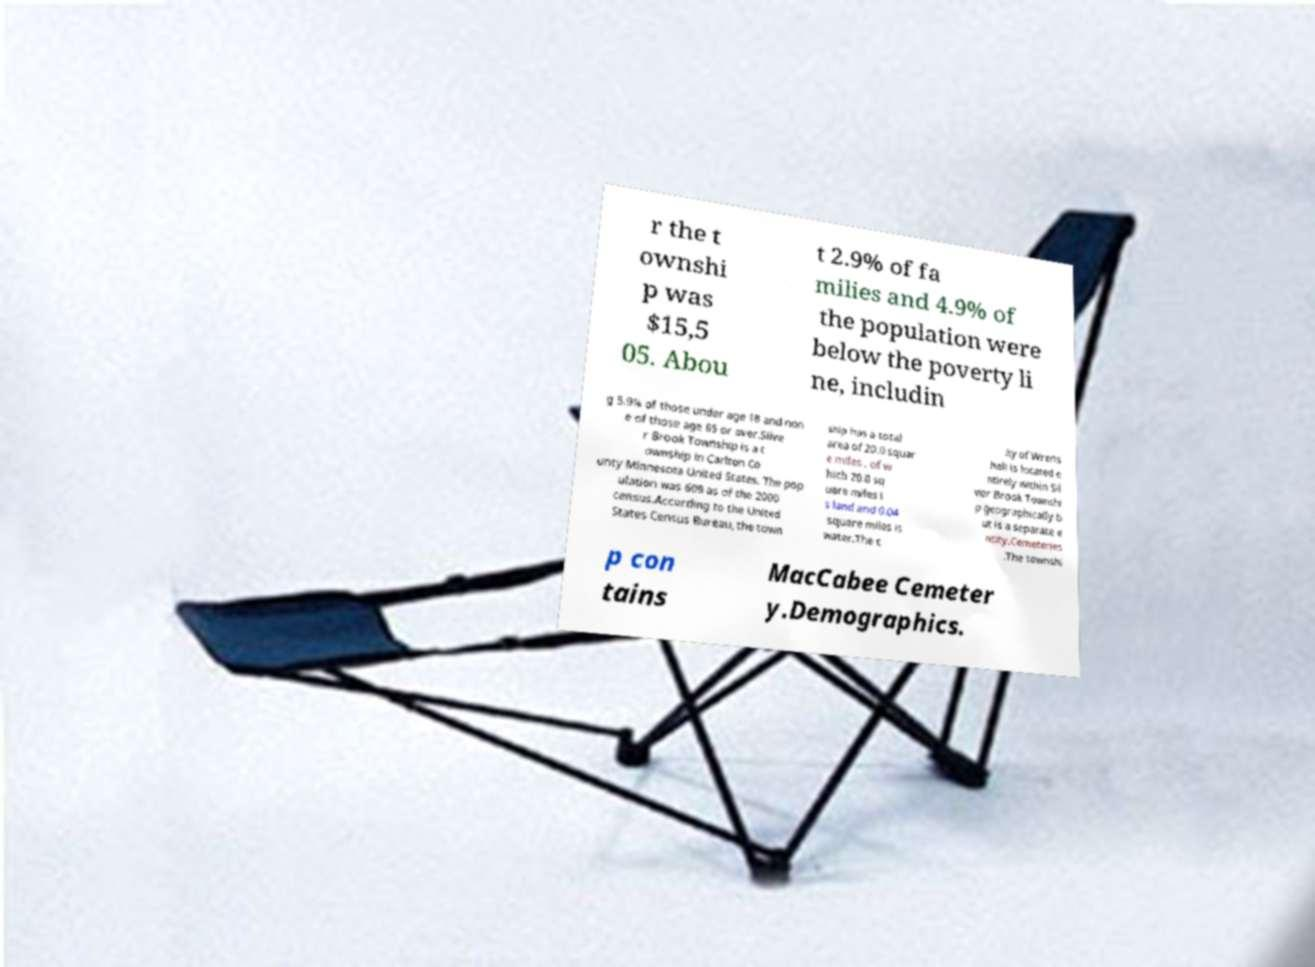I need the written content from this picture converted into text. Can you do that? r the t ownshi p was $15,5 05. Abou t 2.9% of fa milies and 4.9% of the population were below the poverty li ne, includin g 5.9% of those under age 18 and non e of those age 65 or over.Silve r Brook Township is a t ownship in Carlton Co unty Minnesota United States. The pop ulation was 609 as of the 2000 census.According to the United States Census Bureau, the town ship has a total area of 20.0 squar e miles , of w hich 20.0 sq uare miles i s land and 0.04 square miles is water.The c ity of Wrens hall is located e ntirely within Sil ver Brook Townshi p geographically b ut is a separate e ntity.Cemeteries .The townshi p con tains MacCabee Cemeter y.Demographics. 